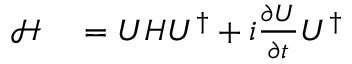<formula> <loc_0><loc_0><loc_500><loc_500>\begin{array} { r l } { \mathcal { H } } & = U H U ^ { \dagger } + i \frac { \partial U } { \partial t } U ^ { \dagger } } \end{array}</formula> 